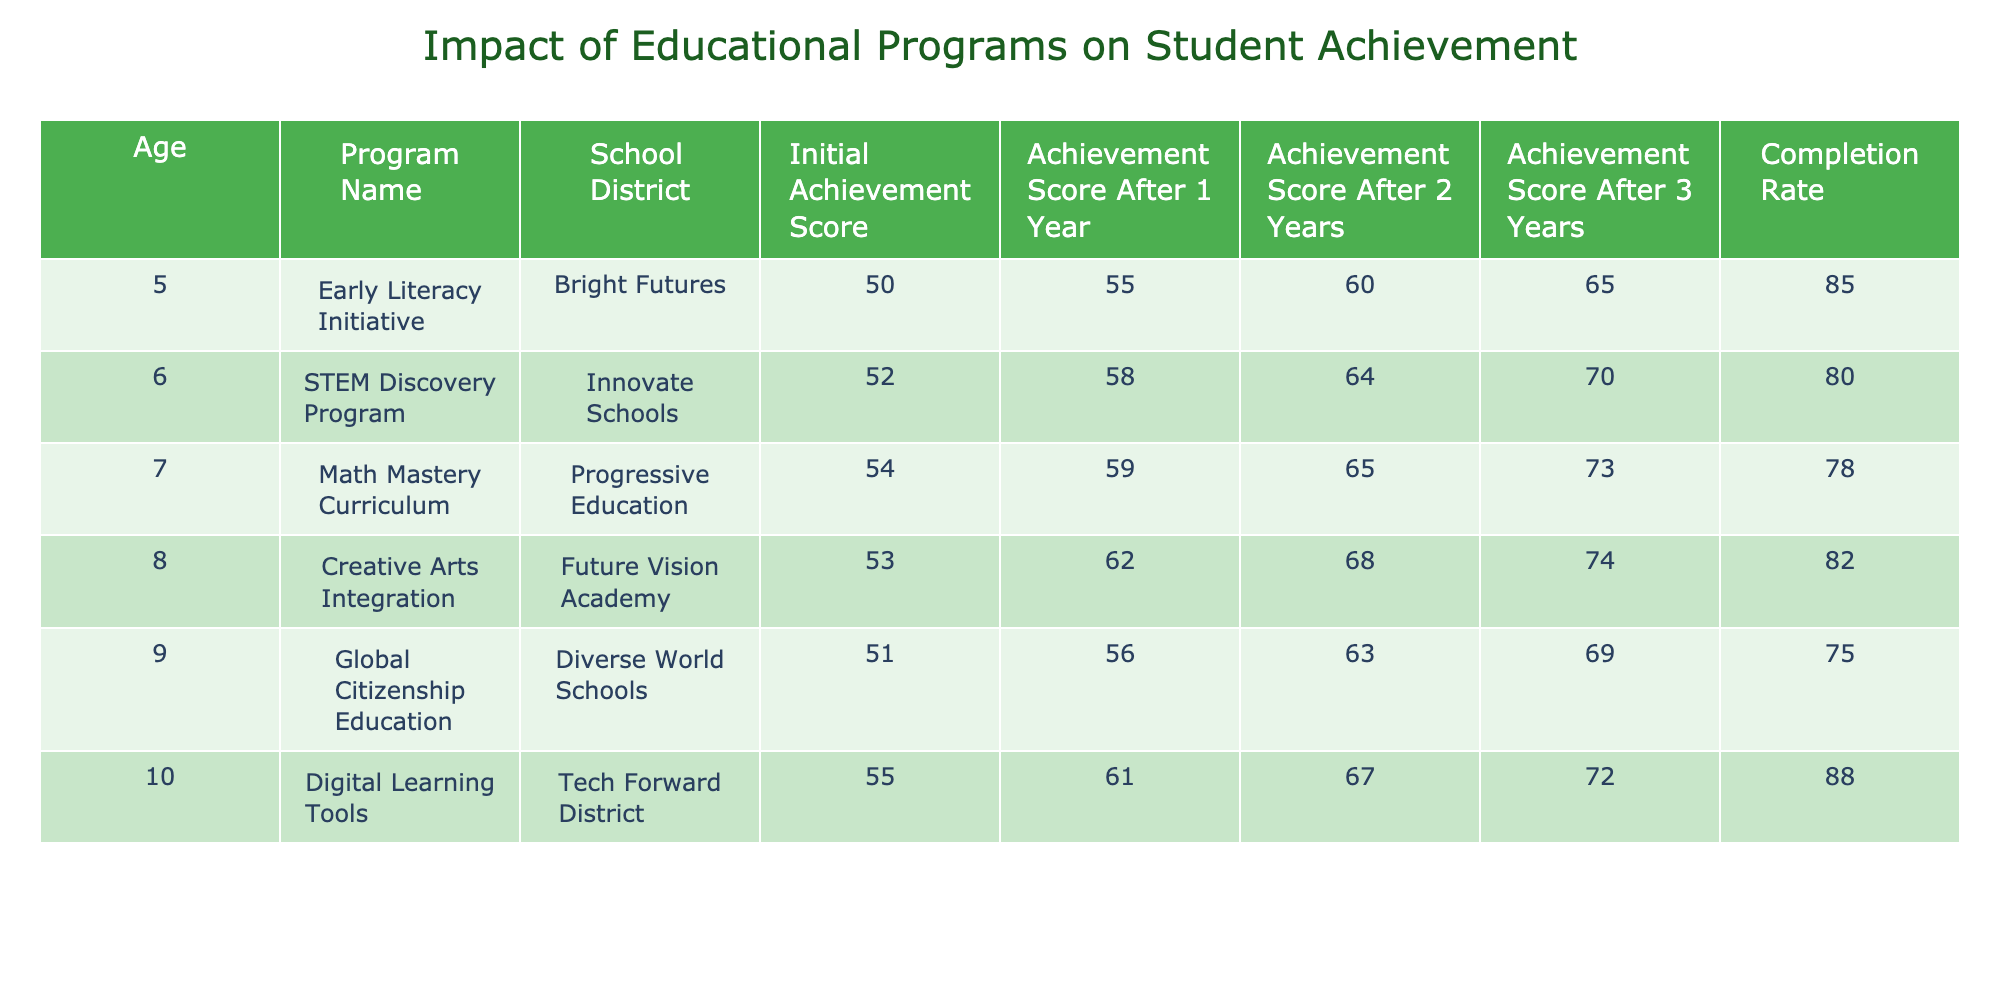What is the completion rate of the Digital Learning Tools program? The table shows the completion rates for various programs. For the Digital Learning Tools program, the specified completion rate is 88.
Answer: 88 Which program had the highest initial achievement score? By looking at the "Initial Achievement Score" column, we can see that the Digital Learning Tools program had the highest score of 55.
Answer: 55 What is the average achievement score after 2 years for all programs? To calculate the average after 2 years, we take the sum of the scores: (60 + 64 + 65 + 68 + 63 + 67) = 387. There are 6 programs, so the average is 387/6 = 64.5.
Answer: 64.5 Did the Global Citizenship Education program improve its achievement score after 3 years? Looking at the achievement scores, the Global Citizenship Education program had a score of 69 after 3 years, showing improvement from the initial score of 51. Therefore, it did improve.
Answer: Yes Which program demonstrated the smallest increase in achievement score from year 1 to year 3? We need to observe the changes from year 1 to year 3 for each program. The Math Mastery Curriculum increased from 59 to 73, showing a change of 14. This was the smallest increase compared to other programs.
Answer: Math Mastery Curriculum What is the difference in achievement scores after 1 year between the Early Literacy Initiative and the STEM Discovery Program? From the table, the Early Literacy Initiative's score after 1 year is 55 and the STEM Discovery Program's score is 58. The difference is 58 - 55, which equals 3.
Answer: 3 Is the completion rate for the Creative Arts Integration program above 80%? The table indicates a completion rate of 82% for the Creative Arts Integration program, which is higher than 80%. Therefore, the answer is yes.
Answer: Yes What is the total achievement score after 1 year for all programs combined? To find the total score after 1 year, we sum the scores after 1 year: (55 + 58 + 59 + 62 + 56 + 61) = 311.
Answer: 311 Which program improved its achievement score the most from the initial score to the score after 3 years? We evaluate each program's initial score and its score after 3 years. The greatest improvement is noted for the STEM Discovery Program, which improved from 52 to 70, resulting in an improvement of 18 points.
Answer: STEM Discovery Program 